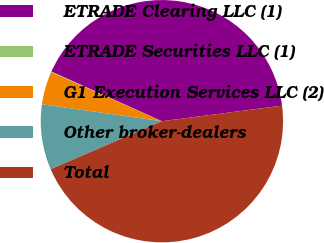Convert chart. <chart><loc_0><loc_0><loc_500><loc_500><pie_chart><fcel>ETRADE Clearing LLC (1)<fcel>ETRADE Securities LLC (1)<fcel>G1 Execution Services LLC (2)<fcel>Other broker-dealers<fcel>Total<nl><fcel>41.23%<fcel>0.08%<fcel>4.4%<fcel>8.72%<fcel>45.55%<nl></chart> 